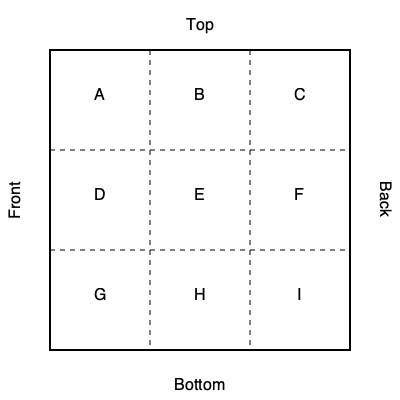You're designing a cuboid-shaped coffee bean package. The 2D net of the package is shown above, with each face labeled A through I. If the package is folded into a 3D shape, which face will be directly opposite to face E? To determine which face is opposite to E in the 3D package, let's follow these steps:

1. Identify the central face: E is in the center of the net, which typically represents one of the larger faces of the cuboid (front or back).

2. Locate the opposite face: In a cuboid, the opposite face to the front would be the back, or vice versa. This opposite face must be one of the other large faces in the net.

3. Analyze the net layout:
   - A, B, and C form the top of the package
   - G, H, and I form the bottom of the package
   - D and F are side faces
   - E is the front face

4. Identify the back face: Given this layout, the back face must be the one that's not adjacent to E when the cube is folded. This would be face A.

5. Verify: If we mentally fold the cube, we can confirm that A would indeed be on the opposite side of E, with B and C folding to form the top, G and I folding to form the bottom, and D and F forming the sides.

Therefore, face A is directly opposite to face E in the 3D package.
Answer: A 